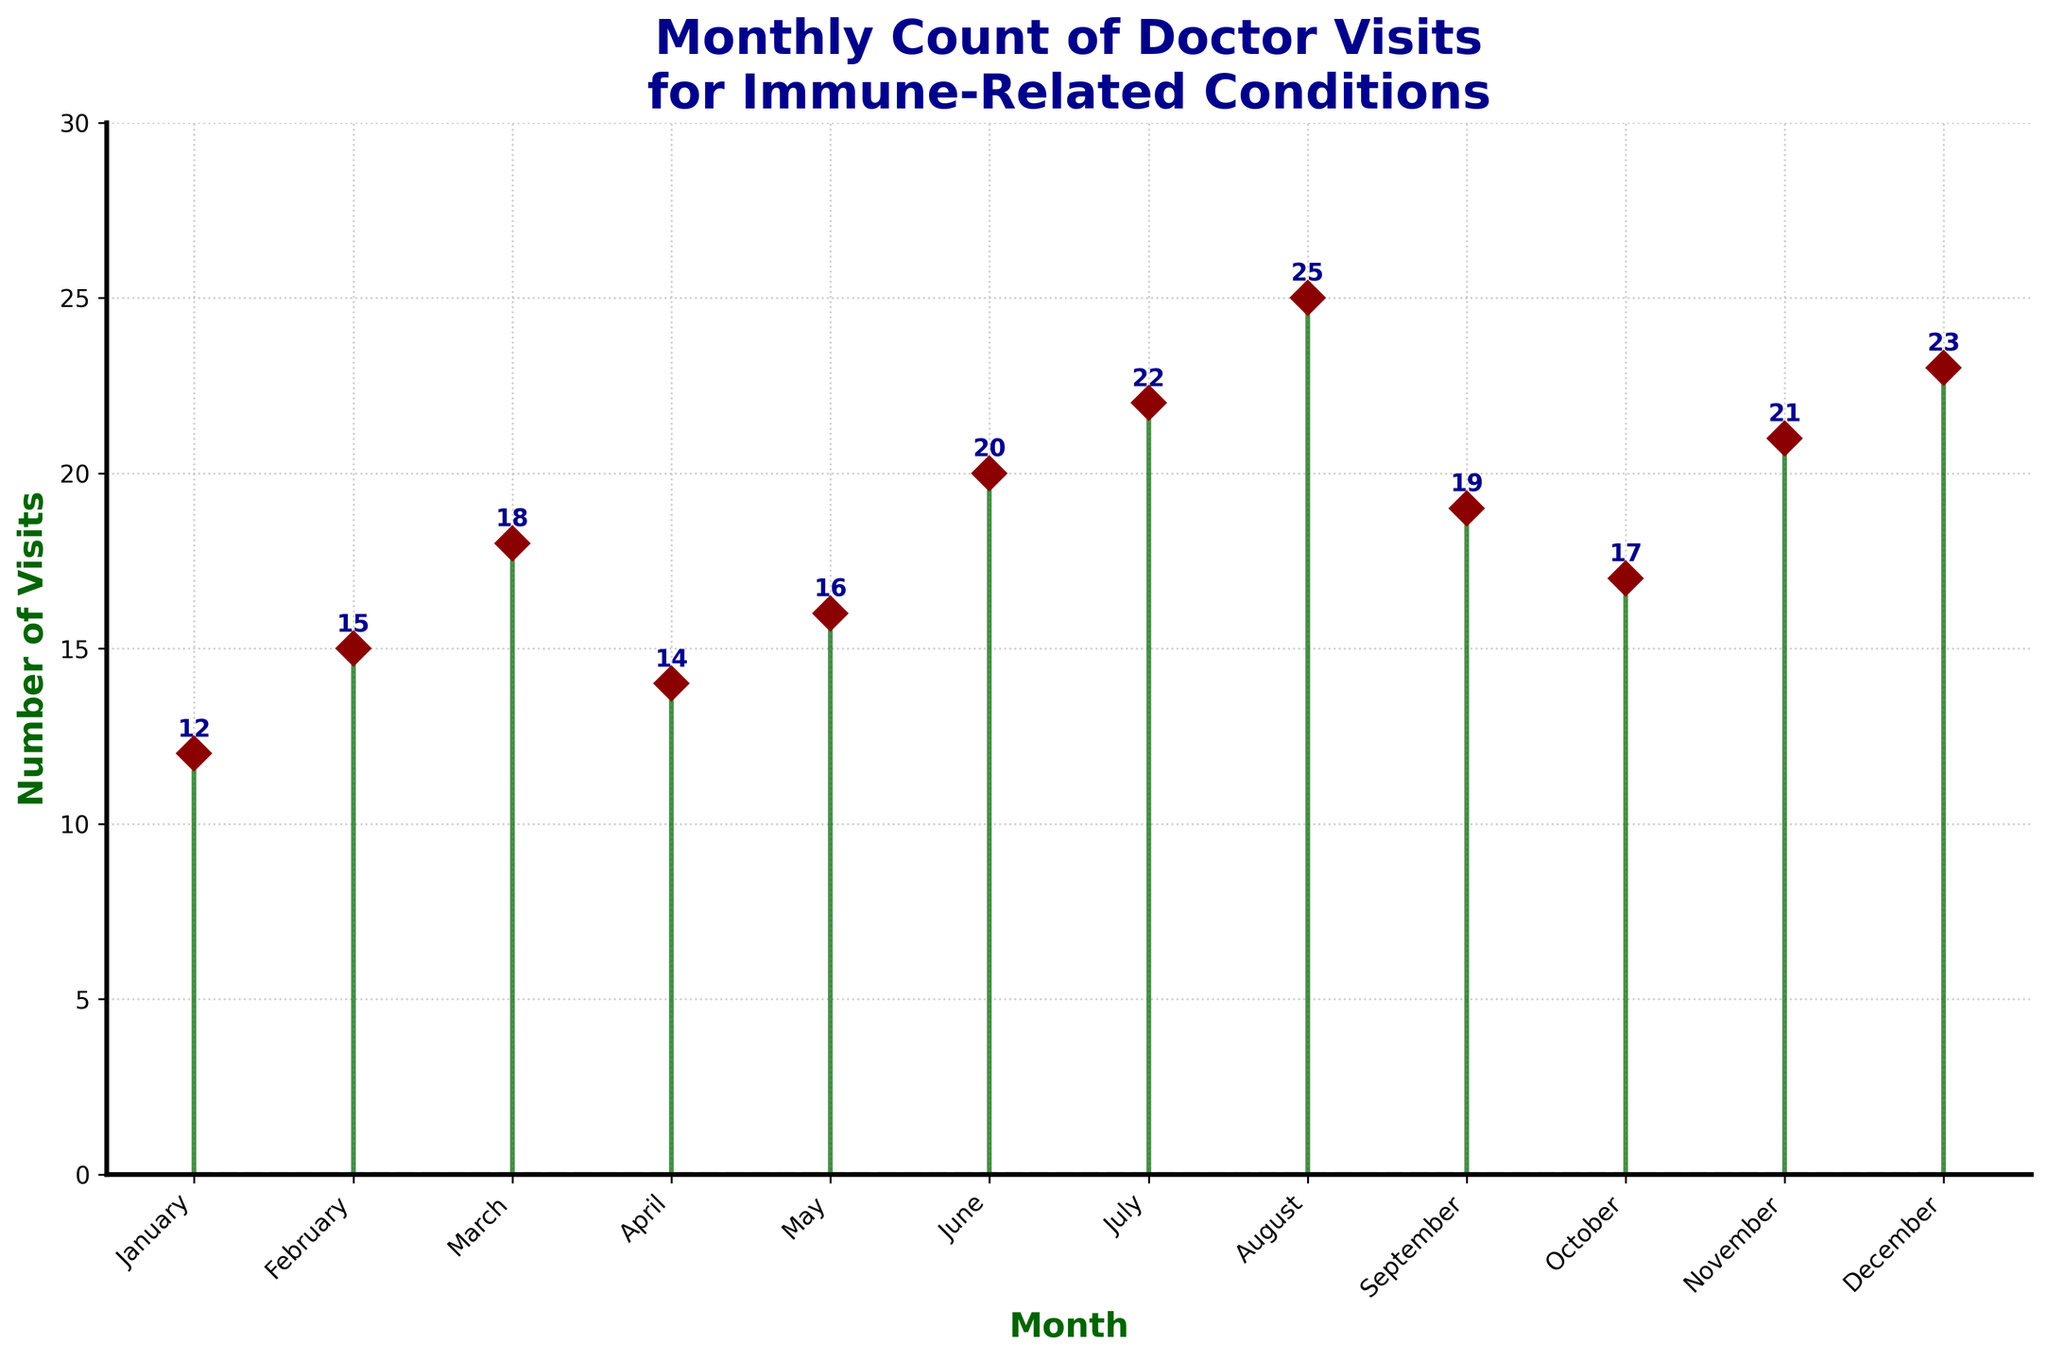What is the highest number of doctor visits in a month? The highest number of doctor visits can be found by looking for the tallest stem in the plot. In this case, it is in August with 25 visits.
Answer: 25 What month has the lowest number of doctor visits? By looking for the shortest stem in the plot, it is clear that January has the lowest number of doctor visits with 12 visits.
Answer: January How many doctor visits were there in June and July combined? To find the total number of visits in June and July, add the values for these months. June has 20 visits and July has 22 visits. 20 + 22 = 42
Answer: 42 Which month had more doctor visits, February or October? By comparing the heights of the stems for February and October, February has 15 visits while October has 17 visits, so October had more visits.
Answer: October What is the average number of doctor visits per month? Add the total number of visits for all the months and divide by the number of months (12). The sum is 12 + 15 + 18 + 14 + 16 + 20 + 22 + 25 + 19 + 17 + 21 + 23 = 222. The average is 222 / 12 = 18.5
Answer: 18.5 Is the number of visits in May greater than in April? Compare the heights of the stems for May and April. April has 14 visits, and May has 16 visits, so May has more visits.
Answer: Yes Does the number of doctor visits increase consistently throughout the year? Check if there's a consistent upward trend in the plot from January to December. The number of visits fluctuates, increasing and decreasing at different points.
Answer: No What is the difference in the number of doctor visits between March and September? To find the difference, subtract the number of visits in March from those in September. March has 18 visits, and September has 19 visits. 19 - 18 = 1
Answer: 1 How many months have doctor visits greater than or equal to 20? Identify the months where the number of visits is 20 or more. These months are June (20), July (22), August (25), November (21), and December (23). That's 5 months.
Answer: 5 What are the three months with the highest number of doctor visits? Find the months with the three tallest stems. These are August (25), December (23), and July (22).
Answer: August, December, July 